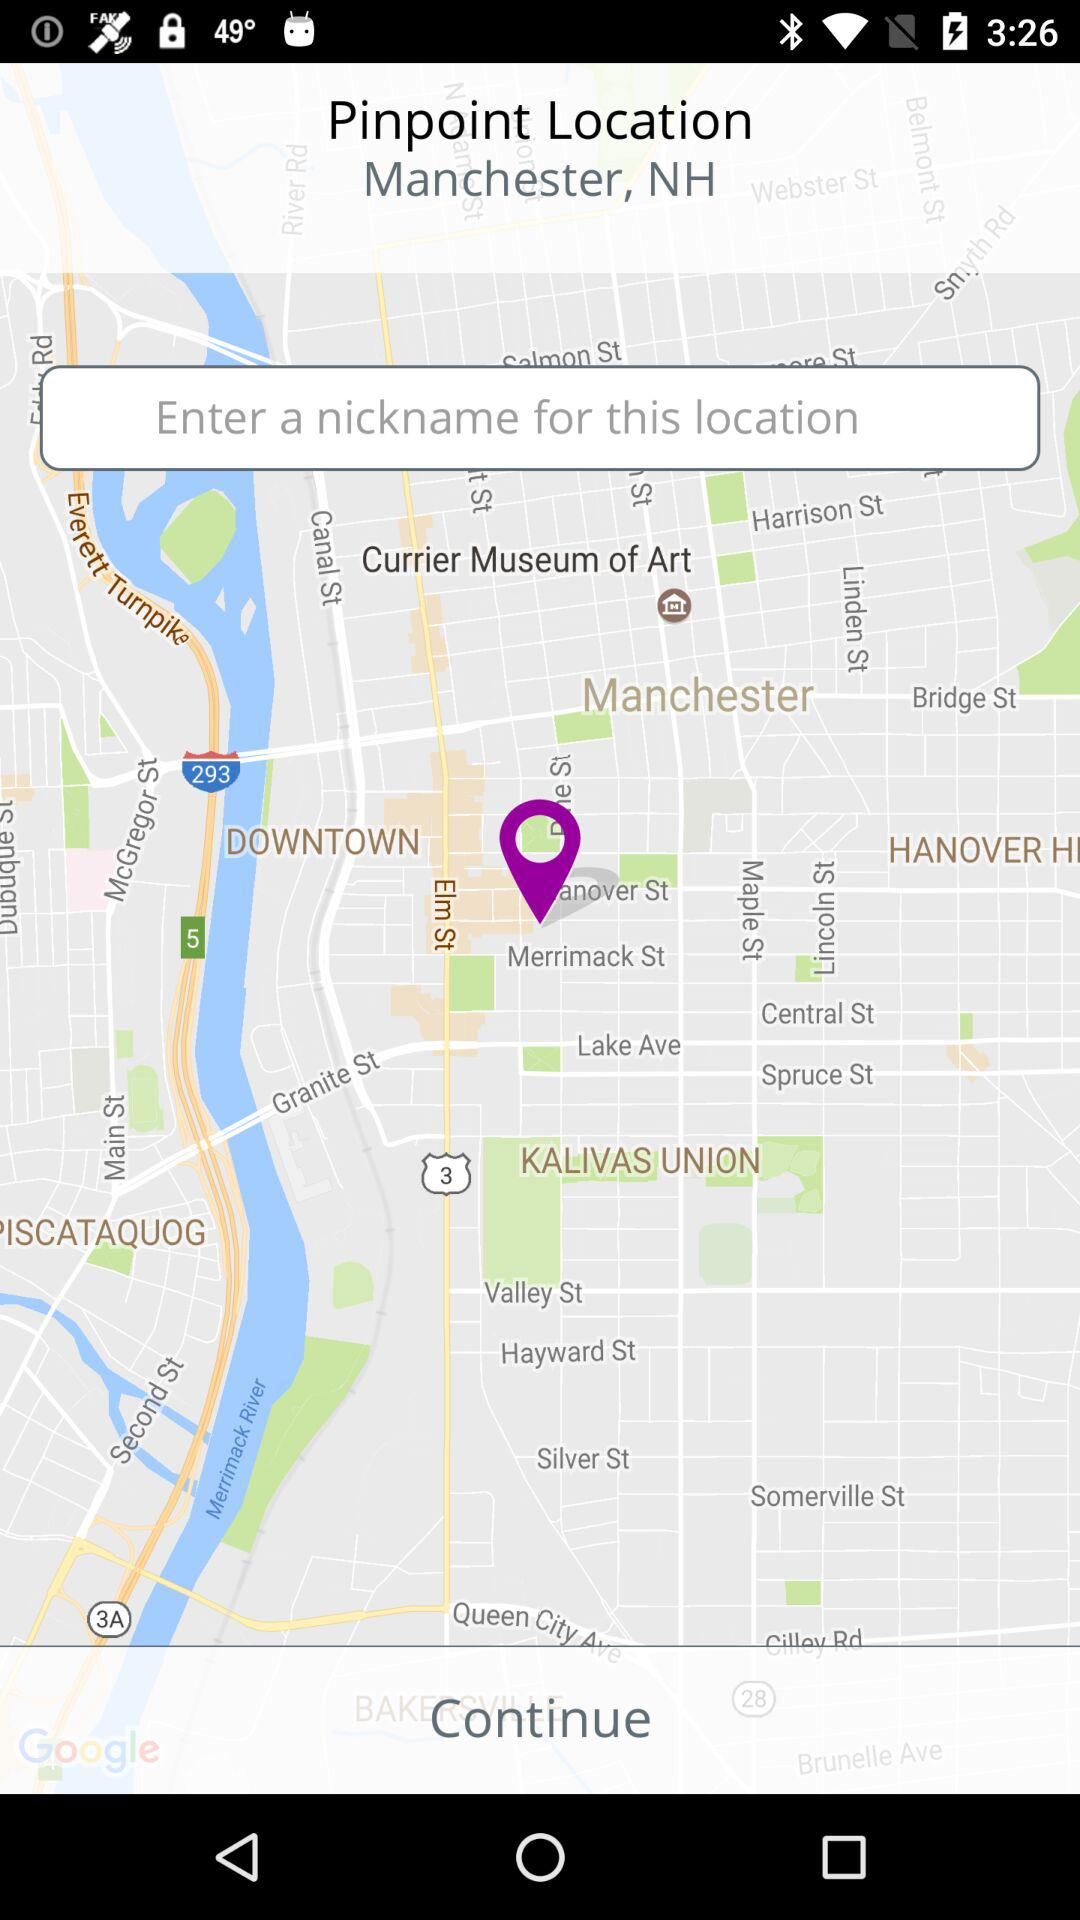What is the nickname for this location?
When the provided information is insufficient, respond with <no answer>. <no answer> 